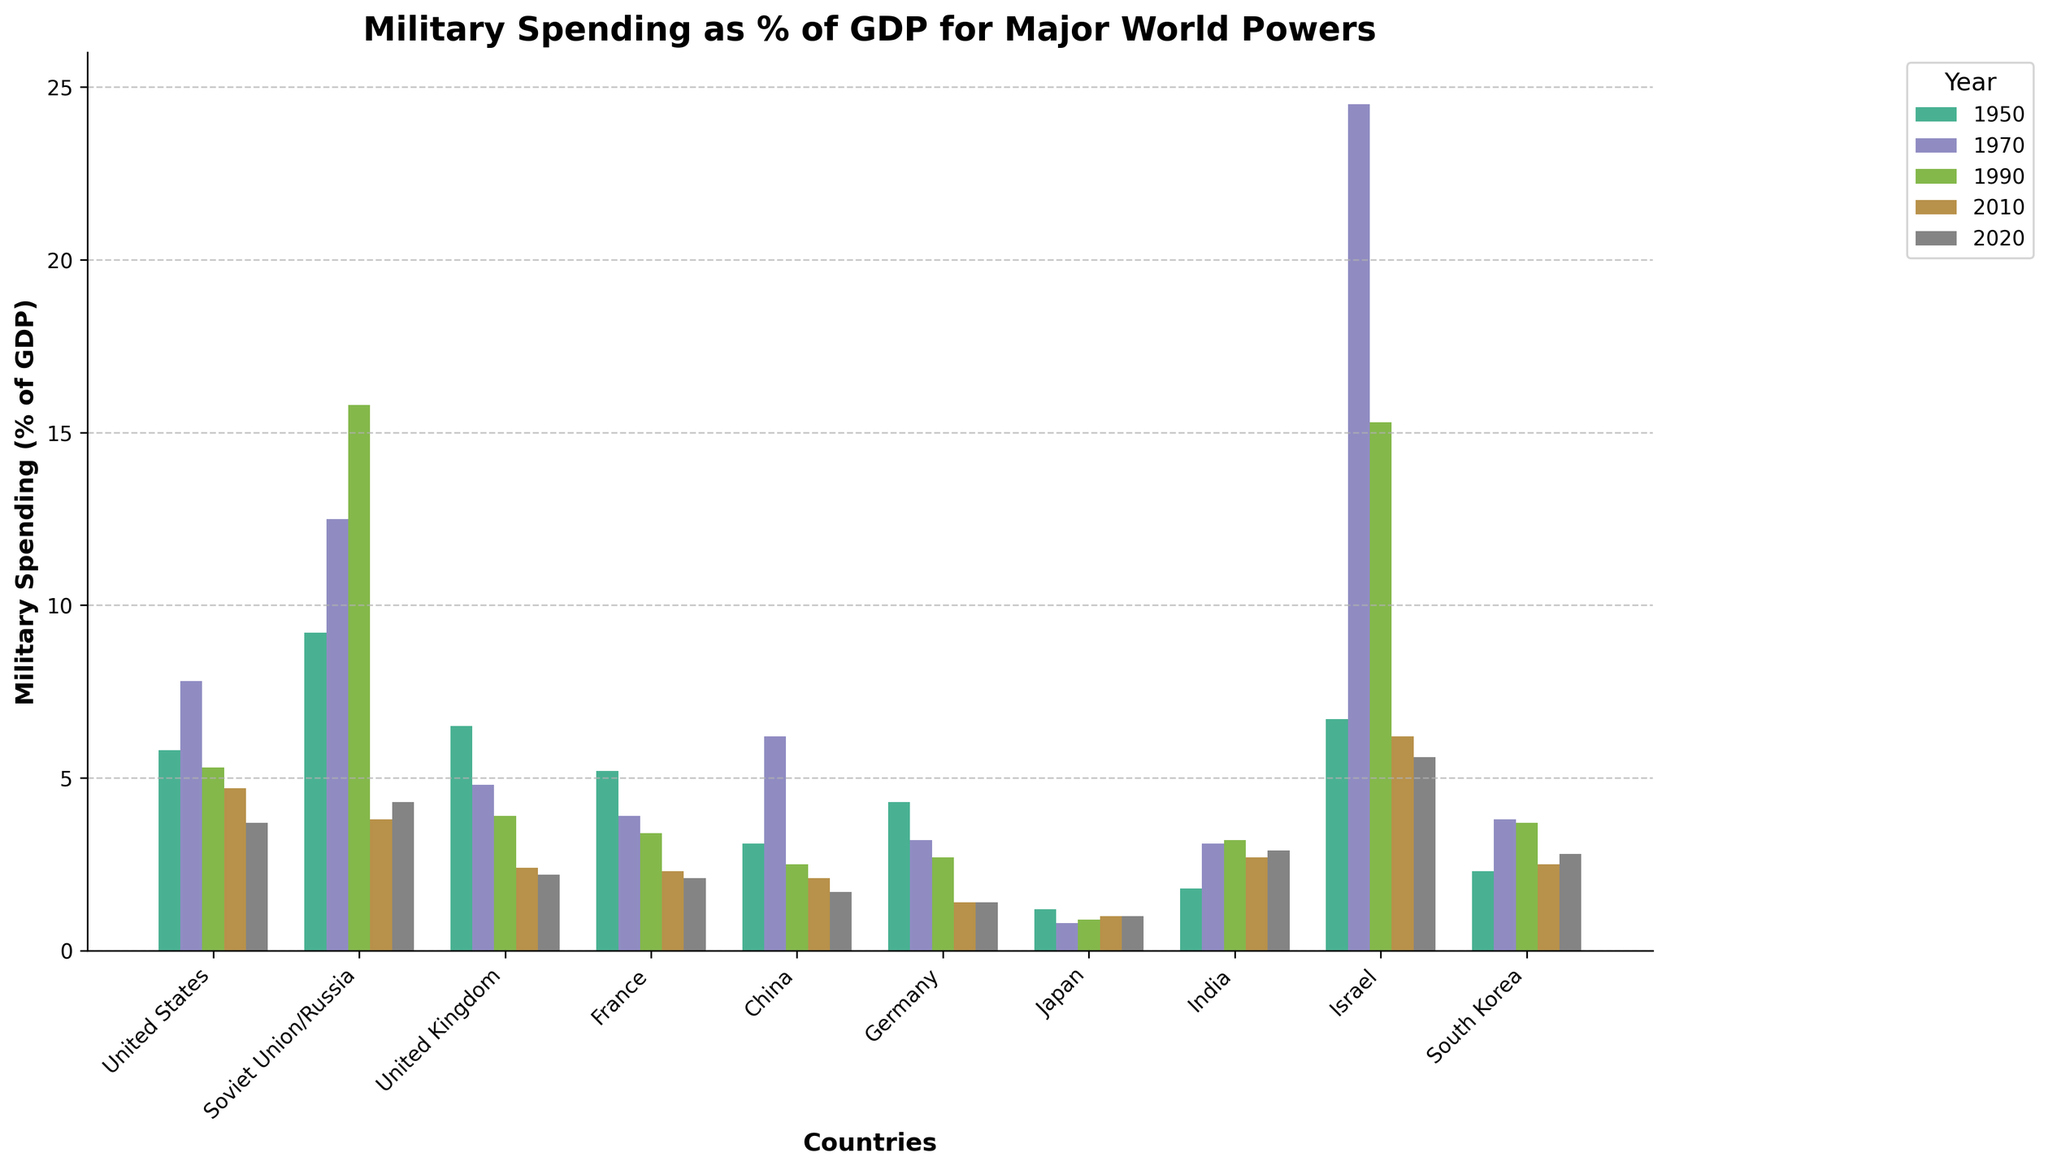Which country had the highest military spending as a percentage of GDP in 1970? By visually inspecting the bar heights for the year 1970, the tallest bar corresponds to Israel.
Answer: Israel Which country has consistently decreased its military spending as a percentage of GDP from 1950 to 2020? By comparing the bar heights for each country from 1950 to 2020, France consistently shows a decrease in military spending over these years.
Answer: France What is the total military spending as a percentage of GDP for the United States in 1950 and 1970? Add the values for the United States in 1950 (5.8%) and 1970 (7.8%) by visual reference. The total is 5.8 + 7.8.
Answer: 13.6% In which year did the Soviet Union/Russia have the highest military spending as a percentage of GDP? By identifying the tallest bar for the Soviet Union/Russia, we observe that the year 1990 has the highest bar at 15.8%.
Answer: 1990 How did Germany's military spending as a percentage of GDP in 1950 compare to that in 2020? Visually compare the bar heights for Germany in 1950 and 2020. In 1950, the bar is higher, indicating higher military spending than in 2020. Specifically, it's 4.3% in 1950 compared to 1.4% in 2020.
Answer: Higher in 1950 What is the difference in military spending as a percentage of GDP between Japan and China in 2020? Visually inspect the bar heights for Japan and China in 2020. For Japan, it's 1.0%, and for China, it's 1.7%. Subtract 1.0 from 1.7.
Answer: 0.7% Which countries had military spending as a percentage of GDP below 2% in the year 2020? Scan the bars for 2020 and identify those below the 2% mark. The countries meeting this criterion are United Kingdom, France, China, Germany, and Japan.
Answer: United Kingdom, France, China, Germany, Japan In which year did the United Kingdom have the highest military spending as a percentage of GDP? By identifying the tallest bar for the United Kingdom, we observe that the year 1950 has the highest bar at 6.5%.
Answer: 1950 How does the military spending as a percentage of GDP of South Korea in 1990 compare to that of India in 1990? Visually compare the bar heights for South Korea and India in 1990. They are very close, with South Korea at 3.7% and India at 3.2%. South Korea's spending is slightly higher.
Answer: South Korea is higher 